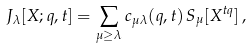Convert formula to latex. <formula><loc_0><loc_0><loc_500><loc_500>J _ { \lambda } [ X ; q , t ] = \sum _ { \mu \geq \lambda } c _ { \mu \lambda } ( q , t ) \, S _ { \mu } [ X ^ { t q } ] \, ,</formula> 